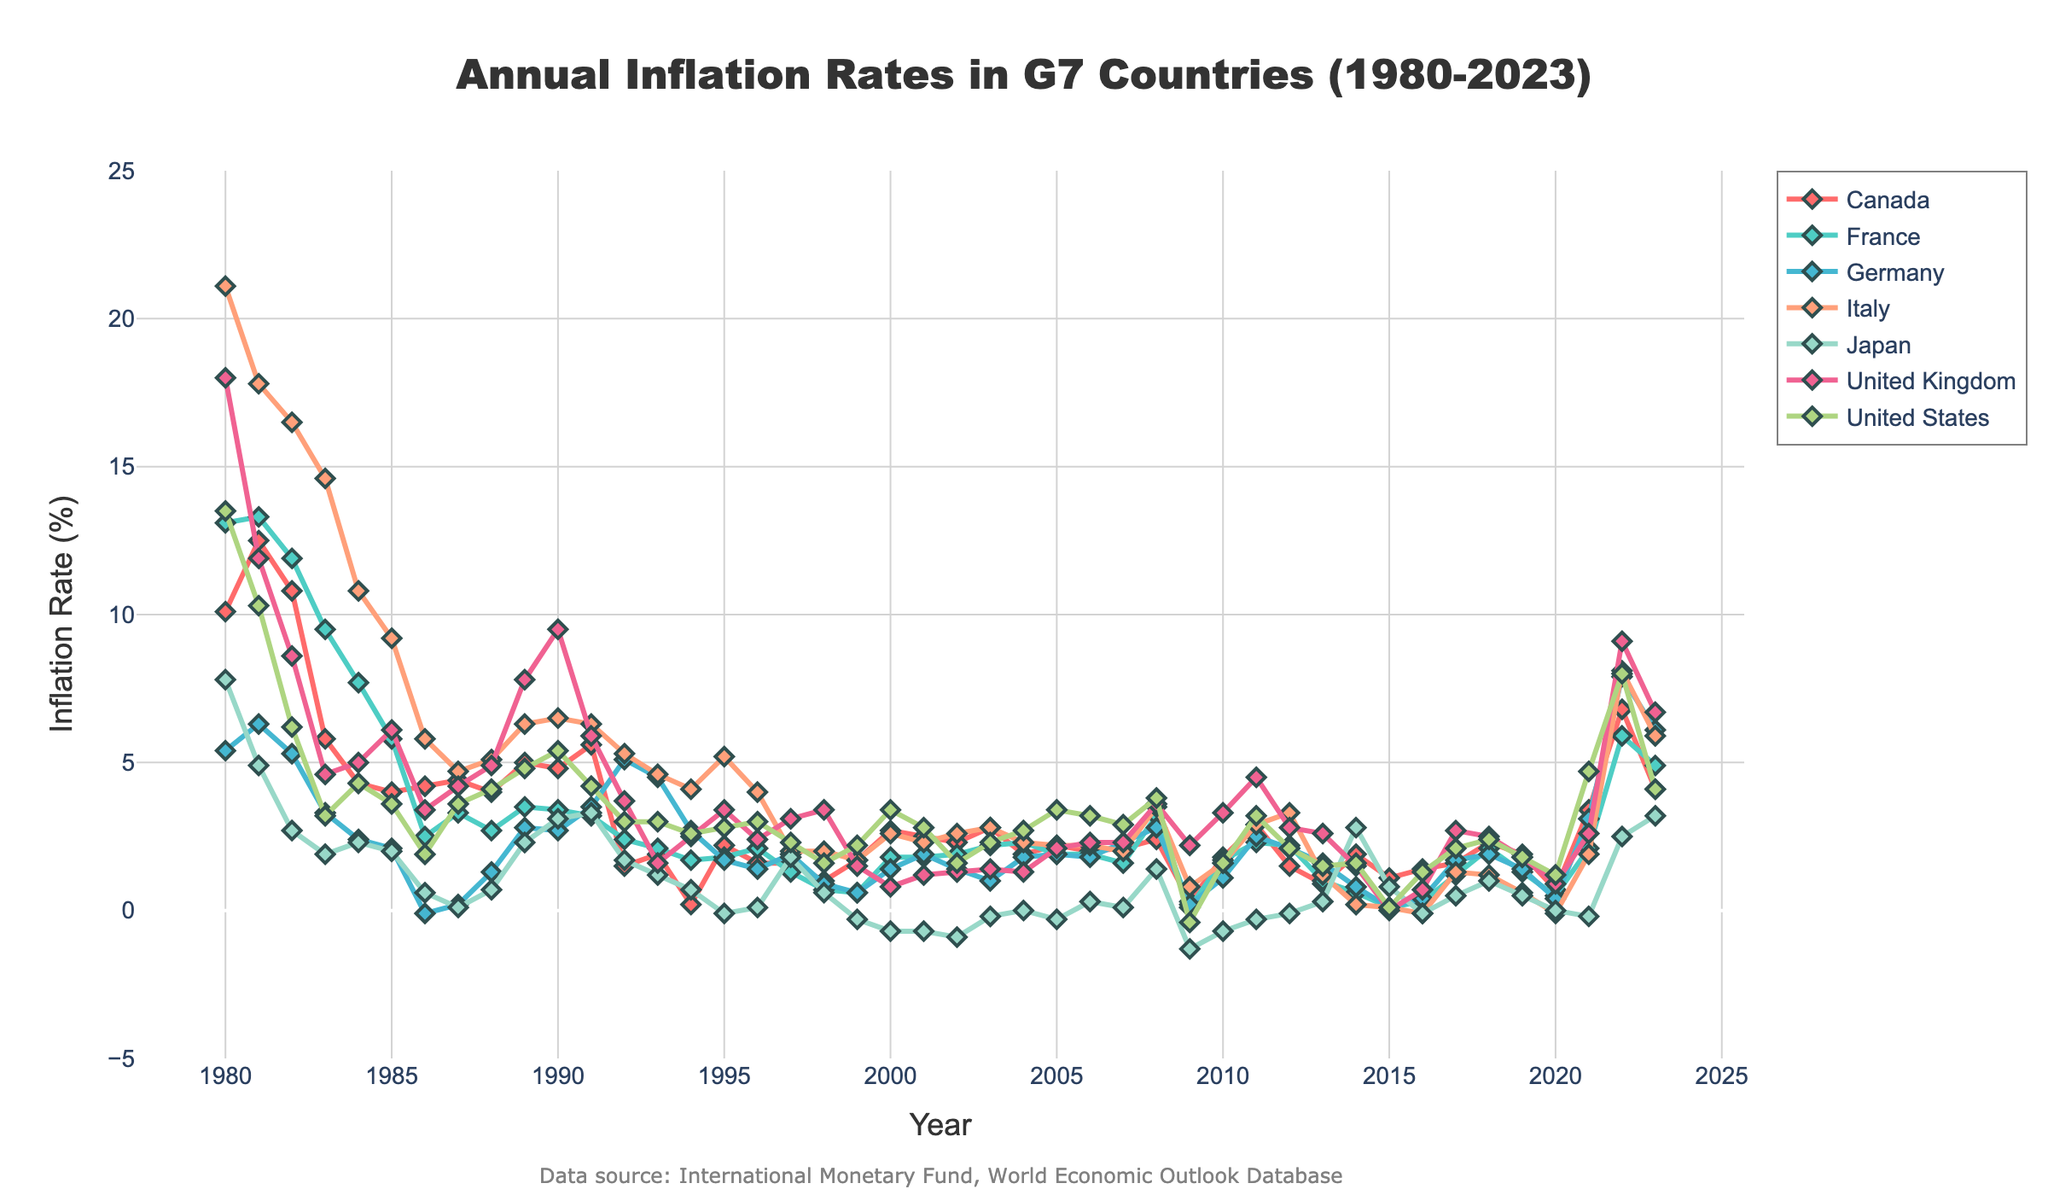Which country had the highest inflation rate in 1980? Look at the y-axis values for each country in 1980. The United Kingdom has the highest value at 18.0%.
Answer: United Kingdom Between 2008 and 2009, which country experienced the largest decrease in inflation rate? Compare the differences in inflation rates between 2008 and 2009 for all countries. The United Kingdom dropped from 3.6% to 2.2%, which is the largest decrease.
Answer: United Kingdom What is the average inflation rate for Japan from 1980 to 2023? Sum up all the inflation rates for Japan from 1980 to 2023, and then divide by the number of years (44). The total is approximately 22.7, so 22.7/44 = 0.52.
Answer: 0.52% Which two countries have the closest inflation rates in 2023? Look at the values for 2023 and identify the two closest inflation rates. Both Canada and the United States have inflation rates of 4.1%.
Answer: Canada and United States In which year did Germany have its lowest inflation rate? Examine the data for Germany across all years and identify the year with the lowest value, which is -0.1% in 1986.
Answer: 1986 What is the overall trend in inflation rates for Italy from 1980 to 2023? Observe the line plot for Italy from 1980 to 2023. The trend is generally decreasing from a high of 21.1% in 1980 to lower values over the years, despite some fluctuations.
Answer: Decreasing Compare the inflation rates of France and Germany in 1992. Which country had a higher inflation rate? Check the values for France and Germany in 1992. Germany had a higher rate at 5.1% compared to France’s 2.4%.
Answer: Germany Which country had the most significant inflation spike in 2022 compared to its previous year? Compare the differences in inflation rates between 2021 and 2022 for all countries. The United States spiked the most from 4.7% to 8.0%.
Answer: United States From 2000 to 2010, which country has the most stable inflation rate (smallest variance)? Examine the plots for each country from 2000 to 2010. Japan shows the least variance, remaining around 0% and slightly below.
Answer: Japan What was the inflation rate trend in the United States during the 1980s? Analyze the United States' line plot from 1980 to 1989. Initially high in 1980 (13.5%), it decreased sharply to 3.2% by 1983 and remained relatively stable around 3-5% for the rest of the decade.
Answer: Declining and then stable 